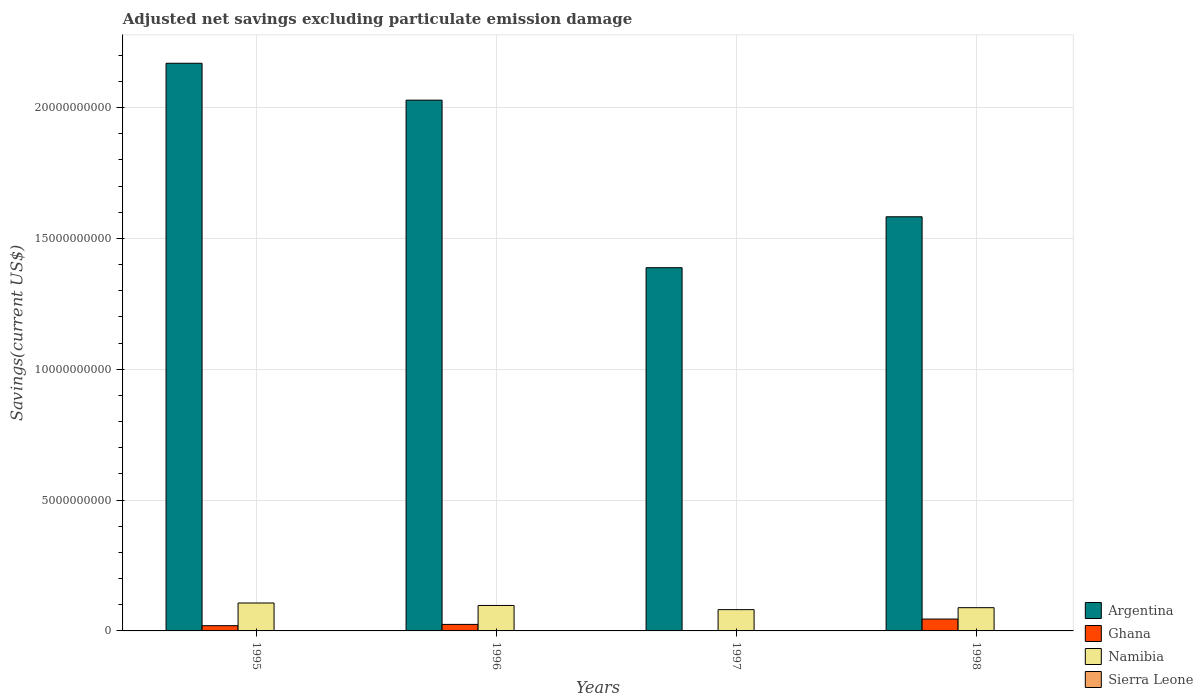Are the number of bars on each tick of the X-axis equal?
Your answer should be very brief. No. What is the label of the 1st group of bars from the left?
Ensure brevity in your answer.  1995. What is the adjusted net savings in Sierra Leone in 1997?
Keep it short and to the point. 0. Across all years, what is the maximum adjusted net savings in Namibia?
Ensure brevity in your answer.  1.07e+09. Across all years, what is the minimum adjusted net savings in Argentina?
Provide a short and direct response. 1.39e+1. In which year was the adjusted net savings in Argentina maximum?
Provide a short and direct response. 1995. What is the total adjusted net savings in Argentina in the graph?
Make the answer very short. 7.17e+1. What is the difference between the adjusted net savings in Argentina in 1995 and that in 1996?
Make the answer very short. 1.41e+09. What is the difference between the adjusted net savings in Sierra Leone in 1996 and the adjusted net savings in Namibia in 1995?
Your answer should be very brief. -1.07e+09. What is the average adjusted net savings in Ghana per year?
Ensure brevity in your answer.  2.26e+08. In the year 1995, what is the difference between the adjusted net savings in Argentina and adjusted net savings in Namibia?
Your response must be concise. 2.06e+1. In how many years, is the adjusted net savings in Namibia greater than 5000000000 US$?
Your answer should be compact. 0. What is the ratio of the adjusted net savings in Argentina in 1997 to that in 1998?
Offer a terse response. 0.88. What is the difference between the highest and the second highest adjusted net savings in Namibia?
Provide a succinct answer. 9.41e+07. What is the difference between the highest and the lowest adjusted net savings in Namibia?
Offer a very short reply. 2.54e+08. Is it the case that in every year, the sum of the adjusted net savings in Ghana and adjusted net savings in Sierra Leone is greater than the adjusted net savings in Argentina?
Keep it short and to the point. No. Are the values on the major ticks of Y-axis written in scientific E-notation?
Offer a terse response. No. Does the graph contain any zero values?
Offer a terse response. Yes. How many legend labels are there?
Make the answer very short. 4. What is the title of the graph?
Your response must be concise. Adjusted net savings excluding particulate emission damage. Does "Turkmenistan" appear as one of the legend labels in the graph?
Give a very brief answer. No. What is the label or title of the X-axis?
Provide a short and direct response. Years. What is the label or title of the Y-axis?
Your answer should be compact. Savings(current US$). What is the Savings(current US$) of Argentina in 1995?
Offer a very short reply. 2.17e+1. What is the Savings(current US$) of Ghana in 1995?
Your answer should be compact. 2.00e+08. What is the Savings(current US$) of Namibia in 1995?
Provide a succinct answer. 1.07e+09. What is the Savings(current US$) of Sierra Leone in 1995?
Offer a terse response. 0. What is the Savings(current US$) of Argentina in 1996?
Ensure brevity in your answer.  2.03e+1. What is the Savings(current US$) in Ghana in 1996?
Provide a short and direct response. 2.49e+08. What is the Savings(current US$) of Namibia in 1996?
Offer a terse response. 9.73e+08. What is the Savings(current US$) of Argentina in 1997?
Ensure brevity in your answer.  1.39e+1. What is the Savings(current US$) of Namibia in 1997?
Make the answer very short. 8.13e+08. What is the Savings(current US$) in Argentina in 1998?
Provide a short and direct response. 1.58e+1. What is the Savings(current US$) in Ghana in 1998?
Offer a very short reply. 4.53e+08. What is the Savings(current US$) of Namibia in 1998?
Offer a very short reply. 8.88e+08. What is the Savings(current US$) of Sierra Leone in 1998?
Make the answer very short. 0. Across all years, what is the maximum Savings(current US$) of Argentina?
Give a very brief answer. 2.17e+1. Across all years, what is the maximum Savings(current US$) in Ghana?
Your answer should be compact. 4.53e+08. Across all years, what is the maximum Savings(current US$) of Namibia?
Give a very brief answer. 1.07e+09. Across all years, what is the minimum Savings(current US$) of Argentina?
Offer a very short reply. 1.39e+1. Across all years, what is the minimum Savings(current US$) in Namibia?
Your response must be concise. 8.13e+08. What is the total Savings(current US$) of Argentina in the graph?
Your answer should be compact. 7.17e+1. What is the total Savings(current US$) of Ghana in the graph?
Offer a very short reply. 9.02e+08. What is the total Savings(current US$) of Namibia in the graph?
Your response must be concise. 3.74e+09. What is the total Savings(current US$) in Sierra Leone in the graph?
Provide a short and direct response. 0. What is the difference between the Savings(current US$) of Argentina in 1995 and that in 1996?
Your answer should be very brief. 1.41e+09. What is the difference between the Savings(current US$) of Ghana in 1995 and that in 1996?
Keep it short and to the point. -4.89e+07. What is the difference between the Savings(current US$) of Namibia in 1995 and that in 1996?
Your response must be concise. 9.41e+07. What is the difference between the Savings(current US$) of Argentina in 1995 and that in 1997?
Your response must be concise. 7.81e+09. What is the difference between the Savings(current US$) in Namibia in 1995 and that in 1997?
Keep it short and to the point. 2.54e+08. What is the difference between the Savings(current US$) of Argentina in 1995 and that in 1998?
Give a very brief answer. 5.87e+09. What is the difference between the Savings(current US$) in Ghana in 1995 and that in 1998?
Ensure brevity in your answer.  -2.53e+08. What is the difference between the Savings(current US$) in Namibia in 1995 and that in 1998?
Your answer should be very brief. 1.79e+08. What is the difference between the Savings(current US$) of Argentina in 1996 and that in 1997?
Your answer should be very brief. 6.40e+09. What is the difference between the Savings(current US$) in Namibia in 1996 and that in 1997?
Your answer should be compact. 1.60e+08. What is the difference between the Savings(current US$) of Argentina in 1996 and that in 1998?
Provide a succinct answer. 4.46e+09. What is the difference between the Savings(current US$) of Ghana in 1996 and that in 1998?
Provide a succinct answer. -2.04e+08. What is the difference between the Savings(current US$) of Namibia in 1996 and that in 1998?
Make the answer very short. 8.50e+07. What is the difference between the Savings(current US$) in Argentina in 1997 and that in 1998?
Make the answer very short. -1.95e+09. What is the difference between the Savings(current US$) of Namibia in 1997 and that in 1998?
Provide a succinct answer. -7.46e+07. What is the difference between the Savings(current US$) in Argentina in 1995 and the Savings(current US$) in Ghana in 1996?
Offer a very short reply. 2.14e+1. What is the difference between the Savings(current US$) in Argentina in 1995 and the Savings(current US$) in Namibia in 1996?
Your answer should be compact. 2.07e+1. What is the difference between the Savings(current US$) in Ghana in 1995 and the Savings(current US$) in Namibia in 1996?
Offer a terse response. -7.73e+08. What is the difference between the Savings(current US$) in Argentina in 1995 and the Savings(current US$) in Namibia in 1997?
Provide a succinct answer. 2.09e+1. What is the difference between the Savings(current US$) of Ghana in 1995 and the Savings(current US$) of Namibia in 1997?
Ensure brevity in your answer.  -6.13e+08. What is the difference between the Savings(current US$) of Argentina in 1995 and the Savings(current US$) of Ghana in 1998?
Give a very brief answer. 2.12e+1. What is the difference between the Savings(current US$) of Argentina in 1995 and the Savings(current US$) of Namibia in 1998?
Offer a terse response. 2.08e+1. What is the difference between the Savings(current US$) in Ghana in 1995 and the Savings(current US$) in Namibia in 1998?
Your answer should be very brief. -6.88e+08. What is the difference between the Savings(current US$) of Argentina in 1996 and the Savings(current US$) of Namibia in 1997?
Provide a short and direct response. 1.95e+1. What is the difference between the Savings(current US$) in Ghana in 1996 and the Savings(current US$) in Namibia in 1997?
Your answer should be very brief. -5.64e+08. What is the difference between the Savings(current US$) of Argentina in 1996 and the Savings(current US$) of Ghana in 1998?
Keep it short and to the point. 1.98e+1. What is the difference between the Savings(current US$) of Argentina in 1996 and the Savings(current US$) of Namibia in 1998?
Give a very brief answer. 1.94e+1. What is the difference between the Savings(current US$) of Ghana in 1996 and the Savings(current US$) of Namibia in 1998?
Offer a terse response. -6.39e+08. What is the difference between the Savings(current US$) in Argentina in 1997 and the Savings(current US$) in Ghana in 1998?
Offer a terse response. 1.34e+1. What is the difference between the Savings(current US$) of Argentina in 1997 and the Savings(current US$) of Namibia in 1998?
Ensure brevity in your answer.  1.30e+1. What is the average Savings(current US$) in Argentina per year?
Give a very brief answer. 1.79e+1. What is the average Savings(current US$) of Ghana per year?
Offer a terse response. 2.26e+08. What is the average Savings(current US$) of Namibia per year?
Provide a short and direct response. 9.35e+08. What is the average Savings(current US$) in Sierra Leone per year?
Give a very brief answer. 0. In the year 1995, what is the difference between the Savings(current US$) in Argentina and Savings(current US$) in Ghana?
Provide a succinct answer. 2.15e+1. In the year 1995, what is the difference between the Savings(current US$) of Argentina and Savings(current US$) of Namibia?
Keep it short and to the point. 2.06e+1. In the year 1995, what is the difference between the Savings(current US$) in Ghana and Savings(current US$) in Namibia?
Make the answer very short. -8.67e+08. In the year 1996, what is the difference between the Savings(current US$) of Argentina and Savings(current US$) of Ghana?
Your answer should be very brief. 2.00e+1. In the year 1996, what is the difference between the Savings(current US$) of Argentina and Savings(current US$) of Namibia?
Give a very brief answer. 1.93e+1. In the year 1996, what is the difference between the Savings(current US$) of Ghana and Savings(current US$) of Namibia?
Offer a very short reply. -7.24e+08. In the year 1997, what is the difference between the Savings(current US$) of Argentina and Savings(current US$) of Namibia?
Make the answer very short. 1.31e+1. In the year 1998, what is the difference between the Savings(current US$) in Argentina and Savings(current US$) in Ghana?
Offer a terse response. 1.54e+1. In the year 1998, what is the difference between the Savings(current US$) in Argentina and Savings(current US$) in Namibia?
Ensure brevity in your answer.  1.49e+1. In the year 1998, what is the difference between the Savings(current US$) of Ghana and Savings(current US$) of Namibia?
Provide a short and direct response. -4.35e+08. What is the ratio of the Savings(current US$) in Argentina in 1995 to that in 1996?
Keep it short and to the point. 1.07. What is the ratio of the Savings(current US$) in Ghana in 1995 to that in 1996?
Offer a very short reply. 0.8. What is the ratio of the Savings(current US$) of Namibia in 1995 to that in 1996?
Your answer should be compact. 1.1. What is the ratio of the Savings(current US$) in Argentina in 1995 to that in 1997?
Provide a succinct answer. 1.56. What is the ratio of the Savings(current US$) of Namibia in 1995 to that in 1997?
Offer a terse response. 1.31. What is the ratio of the Savings(current US$) of Argentina in 1995 to that in 1998?
Offer a terse response. 1.37. What is the ratio of the Savings(current US$) in Ghana in 1995 to that in 1998?
Your response must be concise. 0.44. What is the ratio of the Savings(current US$) in Namibia in 1995 to that in 1998?
Your answer should be very brief. 1.2. What is the ratio of the Savings(current US$) in Argentina in 1996 to that in 1997?
Your answer should be very brief. 1.46. What is the ratio of the Savings(current US$) of Namibia in 1996 to that in 1997?
Your response must be concise. 1.2. What is the ratio of the Savings(current US$) of Argentina in 1996 to that in 1998?
Offer a very short reply. 1.28. What is the ratio of the Savings(current US$) of Ghana in 1996 to that in 1998?
Give a very brief answer. 0.55. What is the ratio of the Savings(current US$) in Namibia in 1996 to that in 1998?
Your answer should be compact. 1.1. What is the ratio of the Savings(current US$) of Argentina in 1997 to that in 1998?
Keep it short and to the point. 0.88. What is the ratio of the Savings(current US$) of Namibia in 1997 to that in 1998?
Provide a succinct answer. 0.92. What is the difference between the highest and the second highest Savings(current US$) in Argentina?
Give a very brief answer. 1.41e+09. What is the difference between the highest and the second highest Savings(current US$) in Ghana?
Make the answer very short. 2.04e+08. What is the difference between the highest and the second highest Savings(current US$) in Namibia?
Provide a succinct answer. 9.41e+07. What is the difference between the highest and the lowest Savings(current US$) in Argentina?
Give a very brief answer. 7.81e+09. What is the difference between the highest and the lowest Savings(current US$) of Ghana?
Ensure brevity in your answer.  4.53e+08. What is the difference between the highest and the lowest Savings(current US$) of Namibia?
Your answer should be compact. 2.54e+08. 